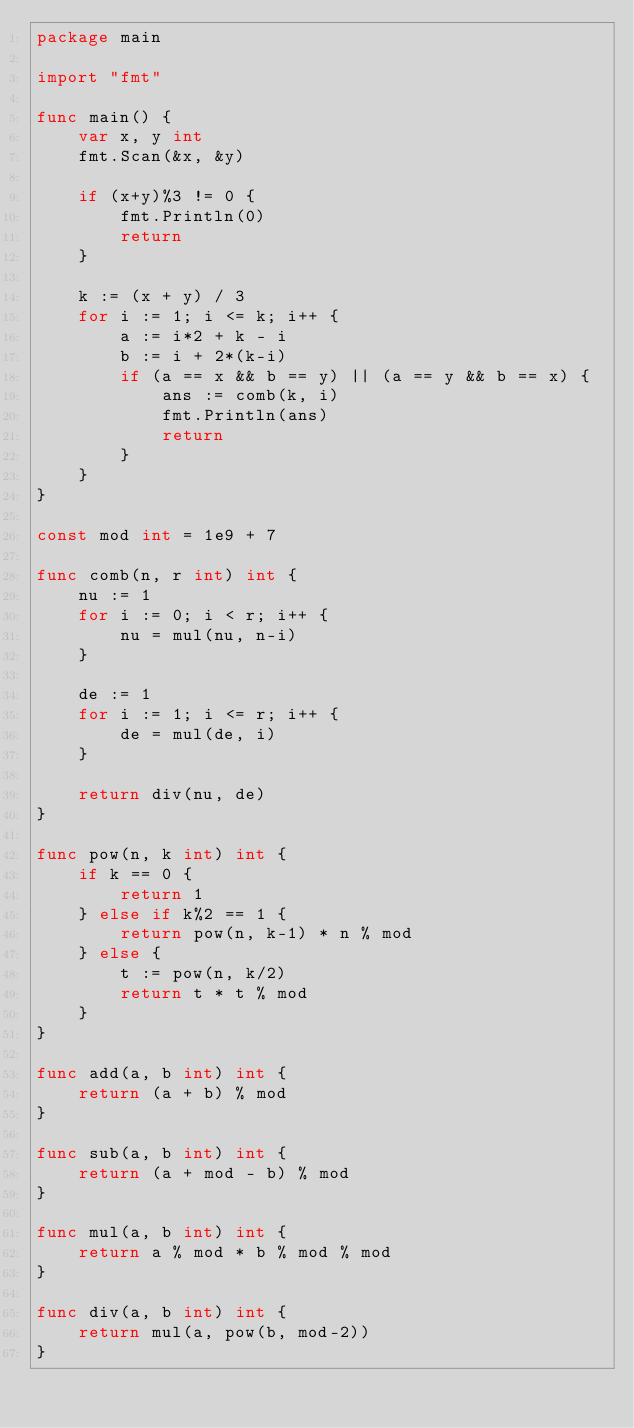<code> <loc_0><loc_0><loc_500><loc_500><_Go_>package main

import "fmt"

func main() {
	var x, y int
	fmt.Scan(&x, &y)

	if (x+y)%3 != 0 {
		fmt.Println(0)
		return
	}

	k := (x + y) / 3
	for i := 1; i <= k; i++ {
		a := i*2 + k - i
		b := i + 2*(k-i)
		if (a == x && b == y) || (a == y && b == x) {
			ans := comb(k, i)
			fmt.Println(ans)
			return
		}
	}
}

const mod int = 1e9 + 7

func comb(n, r int) int {
	nu := 1
	for i := 0; i < r; i++ {
		nu = mul(nu, n-i)
	}

	de := 1
	for i := 1; i <= r; i++ {
		de = mul(de, i)
	}

	return div(nu, de)
}

func pow(n, k int) int {
	if k == 0 {
		return 1
	} else if k%2 == 1 {
		return pow(n, k-1) * n % mod
	} else {
		t := pow(n, k/2)
		return t * t % mod
	}
}

func add(a, b int) int {
	return (a + b) % mod
}

func sub(a, b int) int {
	return (a + mod - b) % mod
}

func mul(a, b int) int {
	return a % mod * b % mod % mod
}

func div(a, b int) int {
	return mul(a, pow(b, mod-2))
}
</code> 